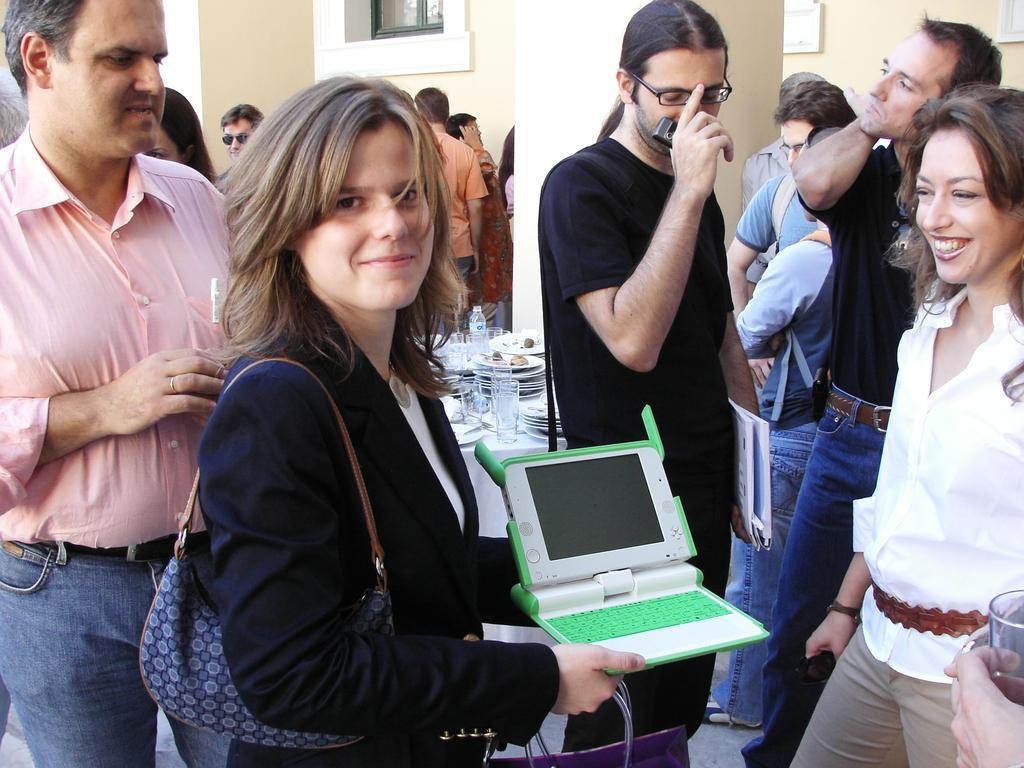How would you summarize this image in a sentence or two? Here in this picture we can see a group of people standing over a place and the woman in the middle is holding a gaming laptop in her hand and also carrying a hand bag and we can see the two women in the front are smiling and the person in the middle is holding a mobile phone and wearing spectacles and behind them we can see a table, on which we can see plates, bottles and we can also see a pillar present. 